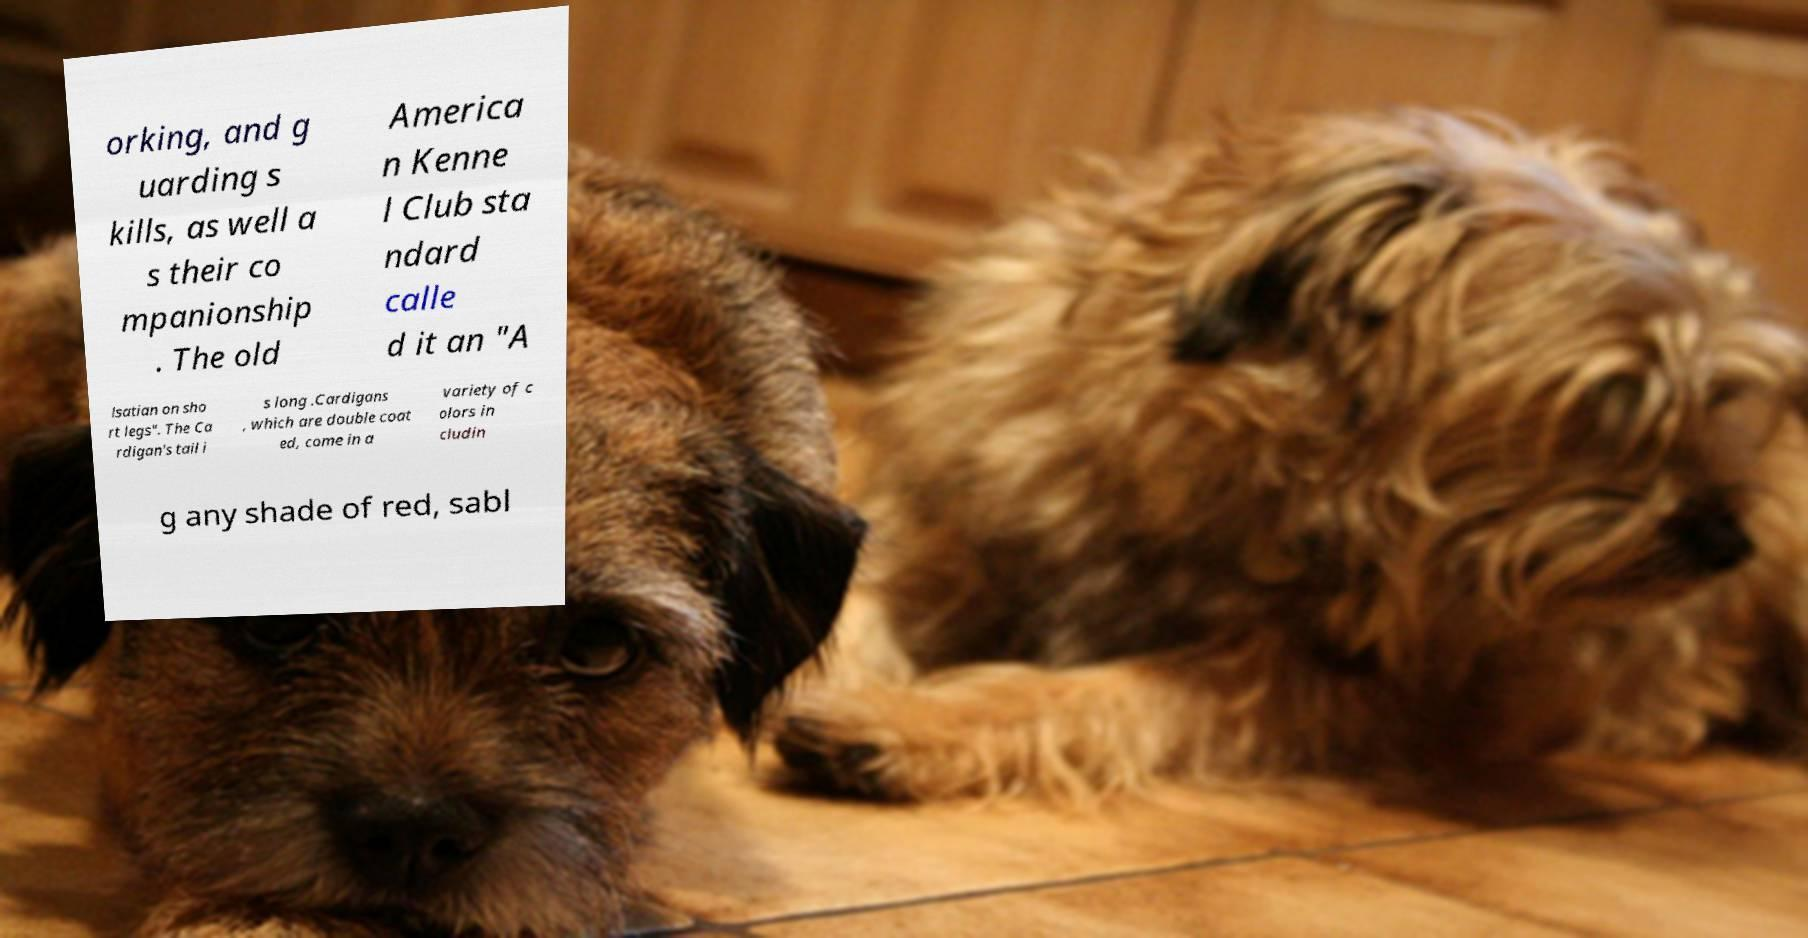There's text embedded in this image that I need extracted. Can you transcribe it verbatim? orking, and g uarding s kills, as well a s their co mpanionship . The old America n Kenne l Club sta ndard calle d it an "A lsatian on sho rt legs". The Ca rdigan's tail i s long .Cardigans , which are double coat ed, come in a variety of c olors in cludin g any shade of red, sabl 